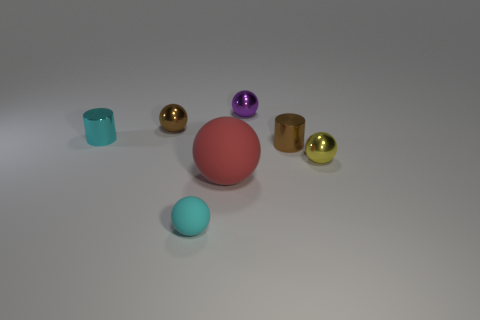Subtract 2 balls. How many balls are left? 3 Subtract all small brown spheres. How many spheres are left? 4 Subtract all red spheres. How many spheres are left? 4 Subtract all green balls. Subtract all cyan cubes. How many balls are left? 5 Add 2 purple metallic cubes. How many objects exist? 9 Subtract all balls. How many objects are left? 2 Add 4 small rubber things. How many small rubber things are left? 5 Add 6 red blocks. How many red blocks exist? 6 Subtract 1 brown spheres. How many objects are left? 6 Subtract all large green shiny cylinders. Subtract all rubber balls. How many objects are left? 5 